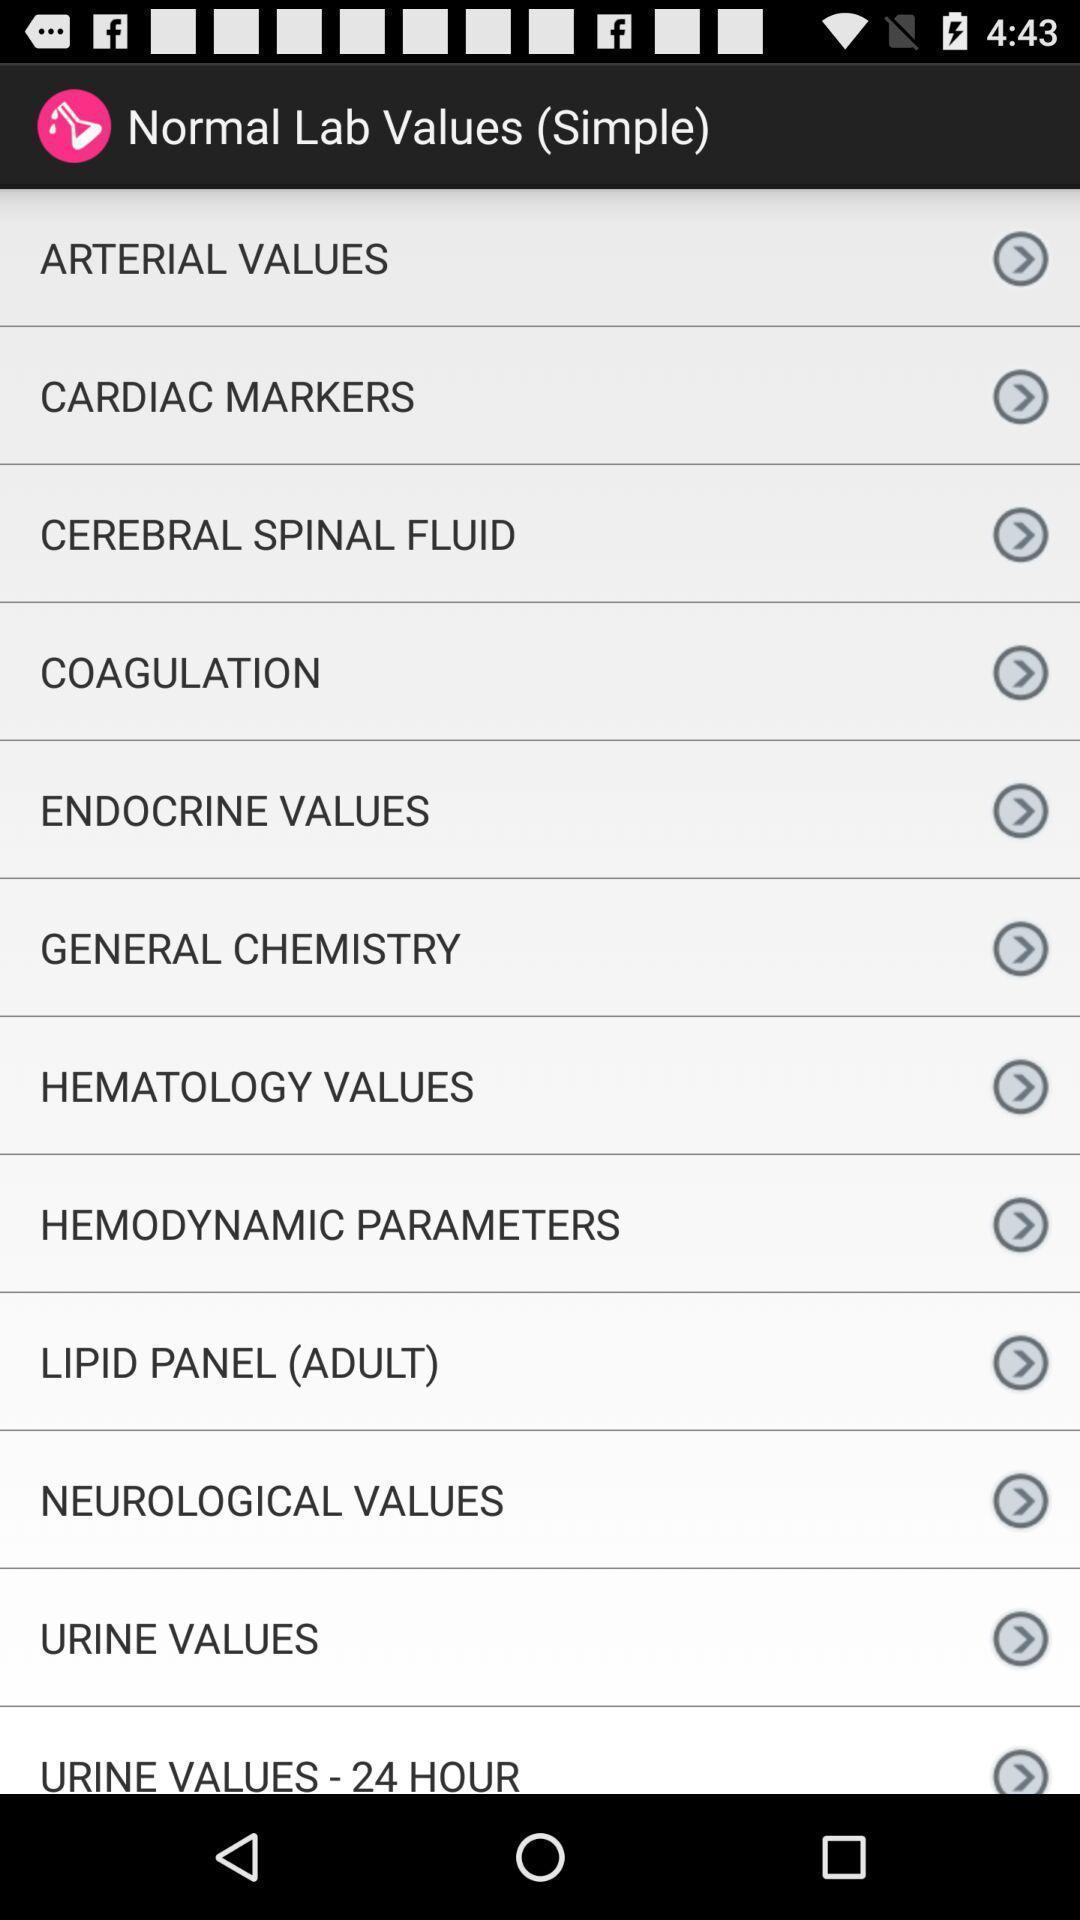Describe the key features of this screenshot. Page showing different lab values. 